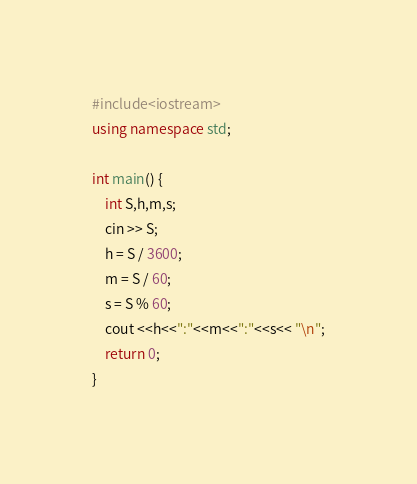<code> <loc_0><loc_0><loc_500><loc_500><_C++_>#include<iostream>
using namespace std;

int main() {
	int S,h,m,s;
	cin >> S;
	h = S / 3600;
	m = S / 60;
	s = S % 60;
	cout <<h<<":"<<m<<":"<<s<< "\n";
	return 0;
}
</code> 